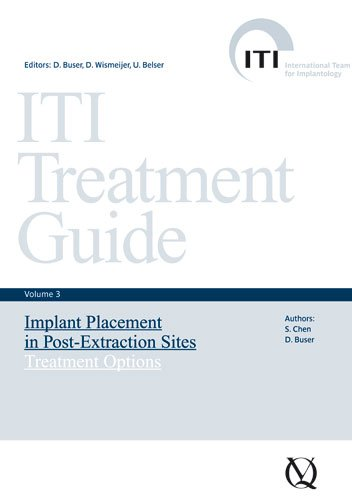Can you explain the main focus of this book? The book primarily deals with the strategies and options for implant placement in dental sites just after a tooth extraction. It offers in-depth advice on how to handle different clinical situations for dental professionals. 